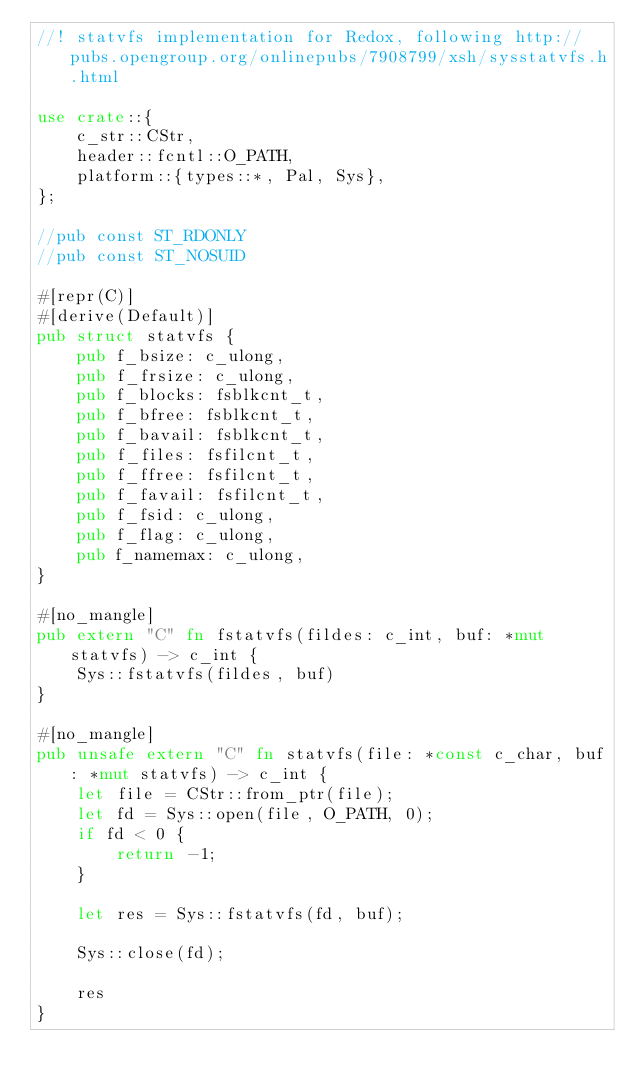<code> <loc_0><loc_0><loc_500><loc_500><_Rust_>//! statvfs implementation for Redox, following http://pubs.opengroup.org/onlinepubs/7908799/xsh/sysstatvfs.h.html

use crate::{
    c_str::CStr,
    header::fcntl::O_PATH,
    platform::{types::*, Pal, Sys},
};

//pub const ST_RDONLY
//pub const ST_NOSUID

#[repr(C)]
#[derive(Default)]
pub struct statvfs {
    pub f_bsize: c_ulong,
    pub f_frsize: c_ulong,
    pub f_blocks: fsblkcnt_t,
    pub f_bfree: fsblkcnt_t,
    pub f_bavail: fsblkcnt_t,
    pub f_files: fsfilcnt_t,
    pub f_ffree: fsfilcnt_t,
    pub f_favail: fsfilcnt_t,
    pub f_fsid: c_ulong,
    pub f_flag: c_ulong,
    pub f_namemax: c_ulong,
}

#[no_mangle]
pub extern "C" fn fstatvfs(fildes: c_int, buf: *mut statvfs) -> c_int {
    Sys::fstatvfs(fildes, buf)
}

#[no_mangle]
pub unsafe extern "C" fn statvfs(file: *const c_char, buf: *mut statvfs) -> c_int {
    let file = CStr::from_ptr(file);
    let fd = Sys::open(file, O_PATH, 0);
    if fd < 0 {
        return -1;
    }

    let res = Sys::fstatvfs(fd, buf);

    Sys::close(fd);

    res
}
</code> 